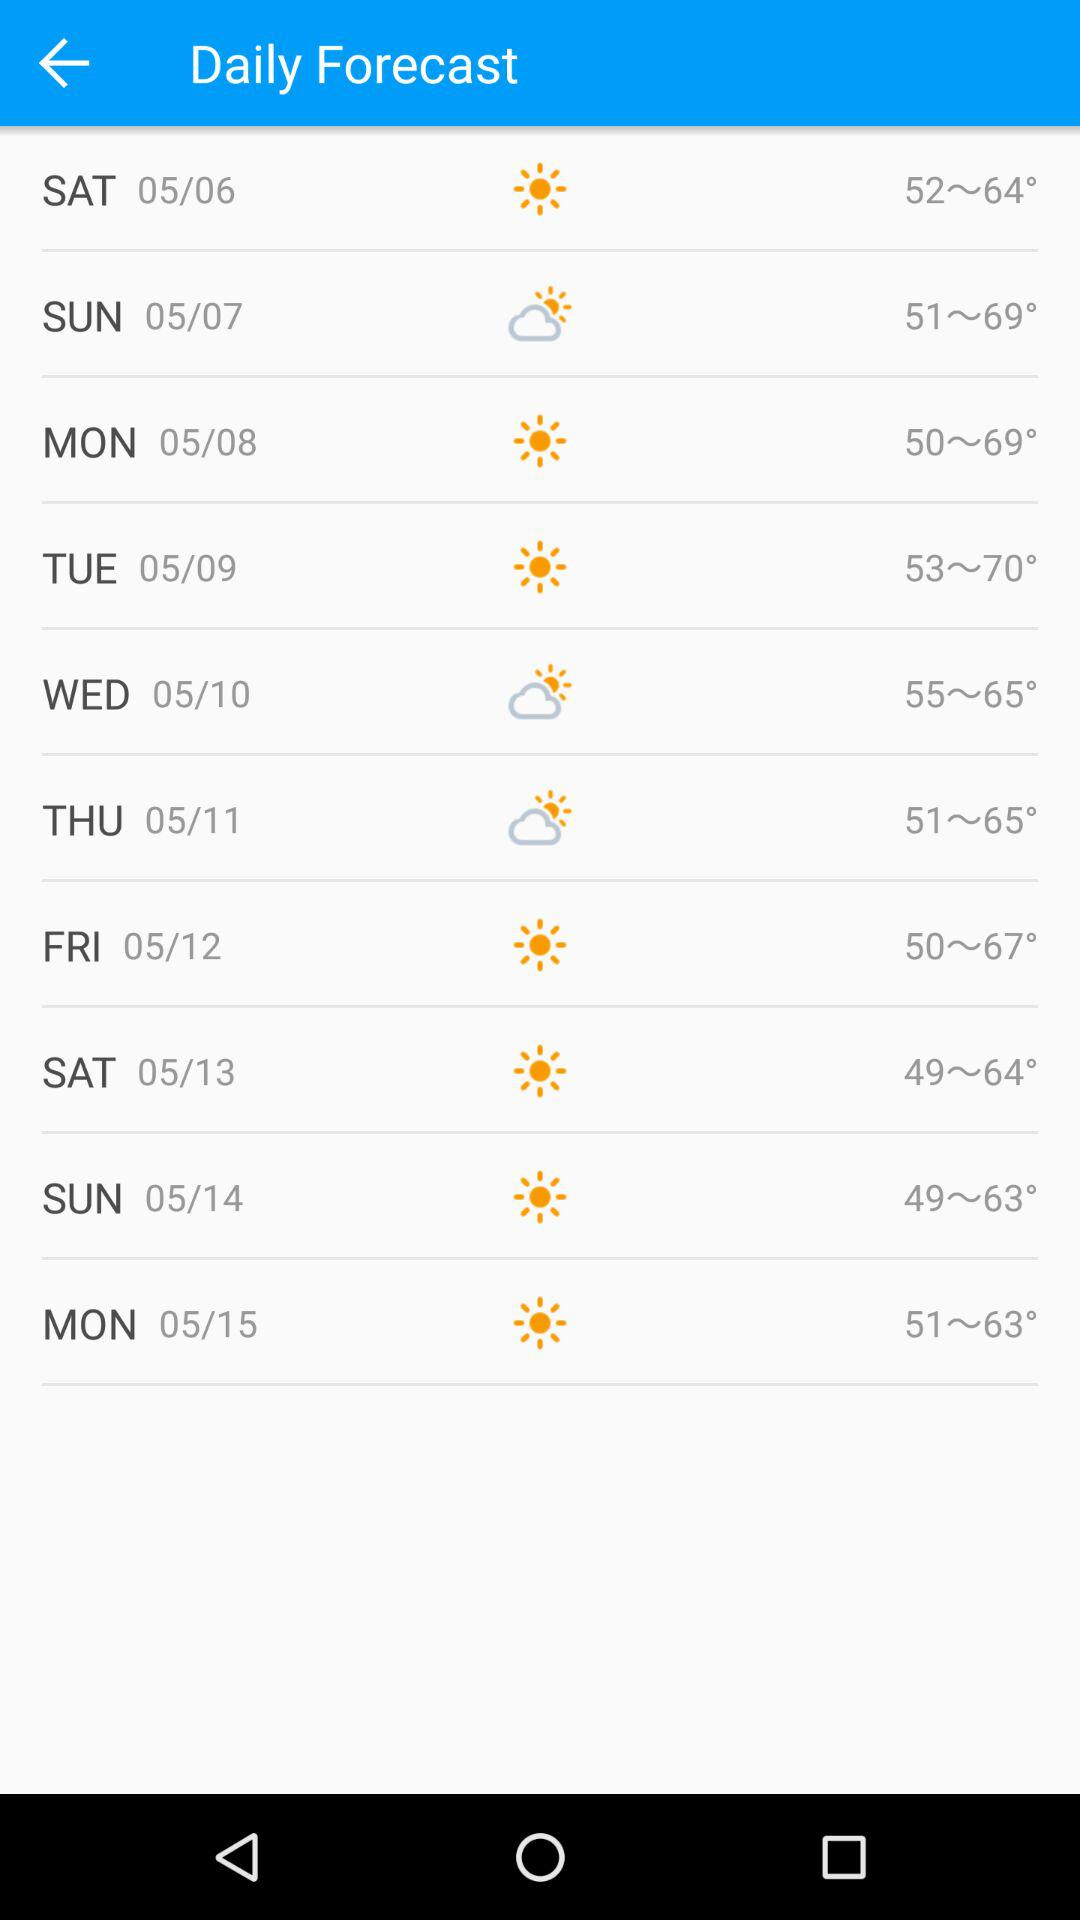How's the weather on 05/06? The weather is "sunny". 